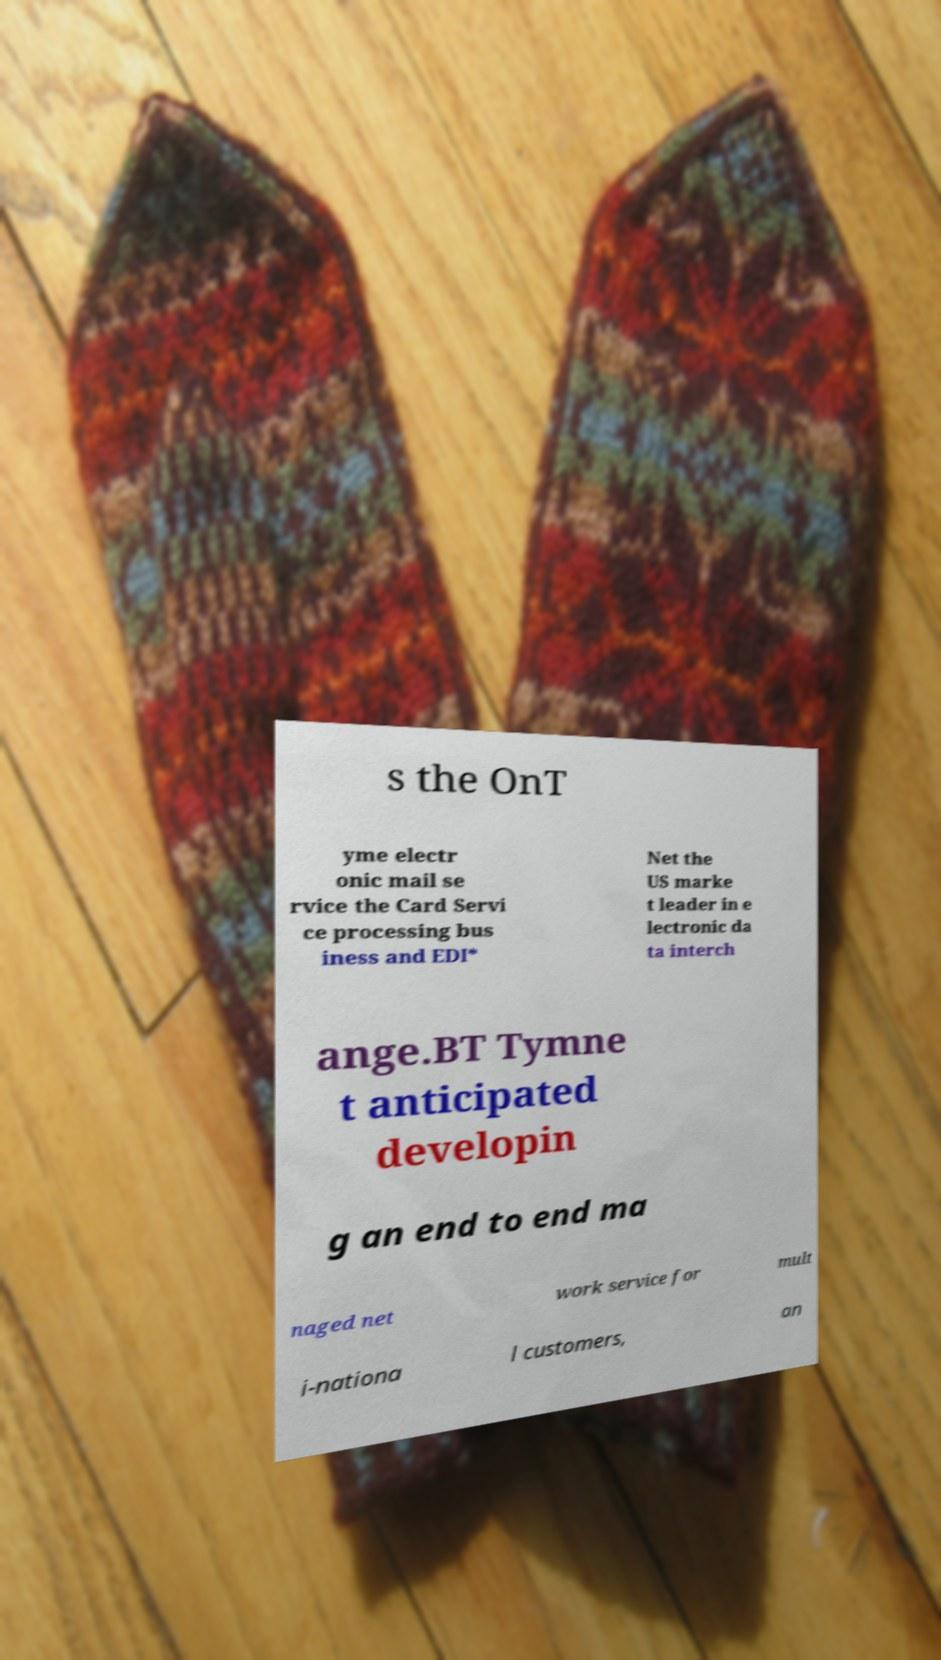I need the written content from this picture converted into text. Can you do that? s the OnT yme electr onic mail se rvice the Card Servi ce processing bus iness and EDI* Net the US marke t leader in e lectronic da ta interch ange.BT Tymne t anticipated developin g an end to end ma naged net work service for mult i-nationa l customers, an 